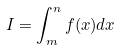<formula> <loc_0><loc_0><loc_500><loc_500>I = \int _ { m } ^ { n } f ( x ) d x</formula> 